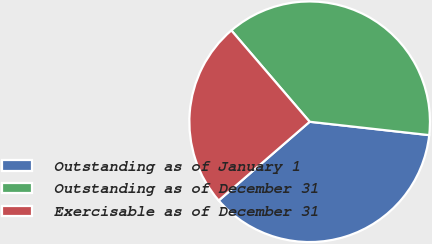Convert chart to OTSL. <chart><loc_0><loc_0><loc_500><loc_500><pie_chart><fcel>Outstanding as of January 1<fcel>Outstanding as of December 31<fcel>Exercisable as of December 31<nl><fcel>36.87%<fcel>38.05%<fcel>25.07%<nl></chart> 